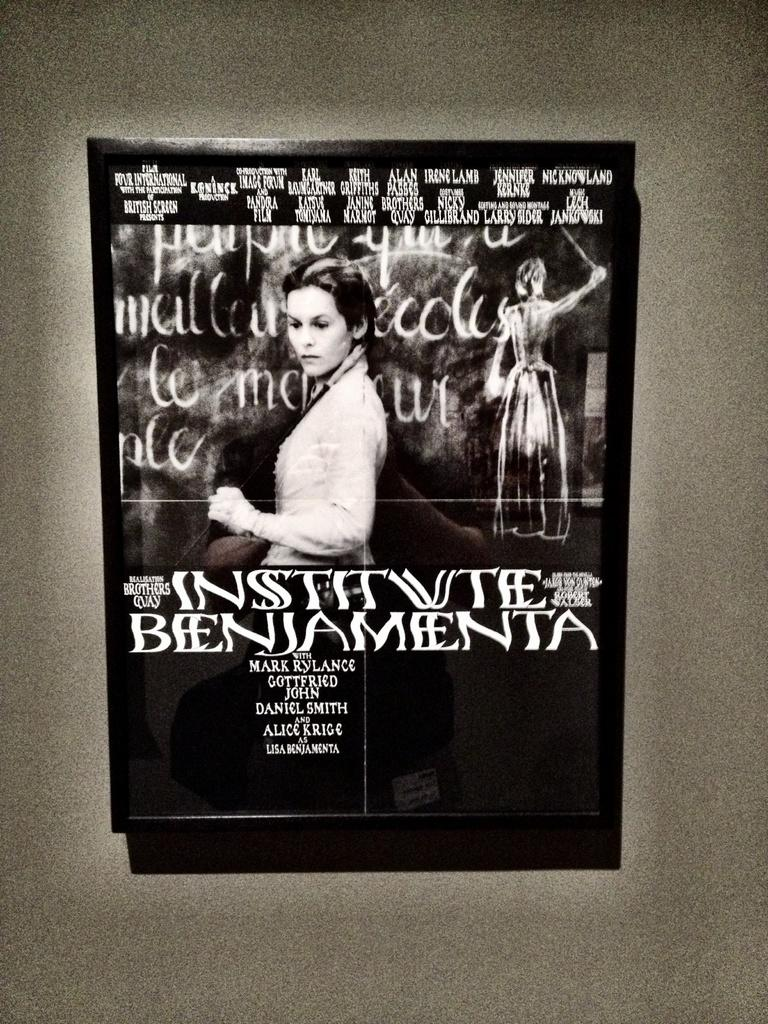What is attached to the wall in the image? There is a board on the wall. What is depicted on the board? There is a picture of a person on the board. Are there any words or phrases on the board? Yes, there is writing on the board. Reasoning: Let' Let's think step by step in order to produce the conversation. We start by identifying the main subject in the image, which is the board on the wall. Then, we expand the conversation to include the details of the board, such as the picture of a person and the writing. Each question is designed to elicit a specific detail about the image that is known from the provided facts. Absurd Question/Answer: What type of carriage is being used to transport the frame in the image? There is no carriage or frame present in the image; it only features a board with a picture of a person and writing on it. What type of beam is supporting the frame in the image? There is no beam or frame present in the image; it only features a board with a picture of a person and writing on it. 